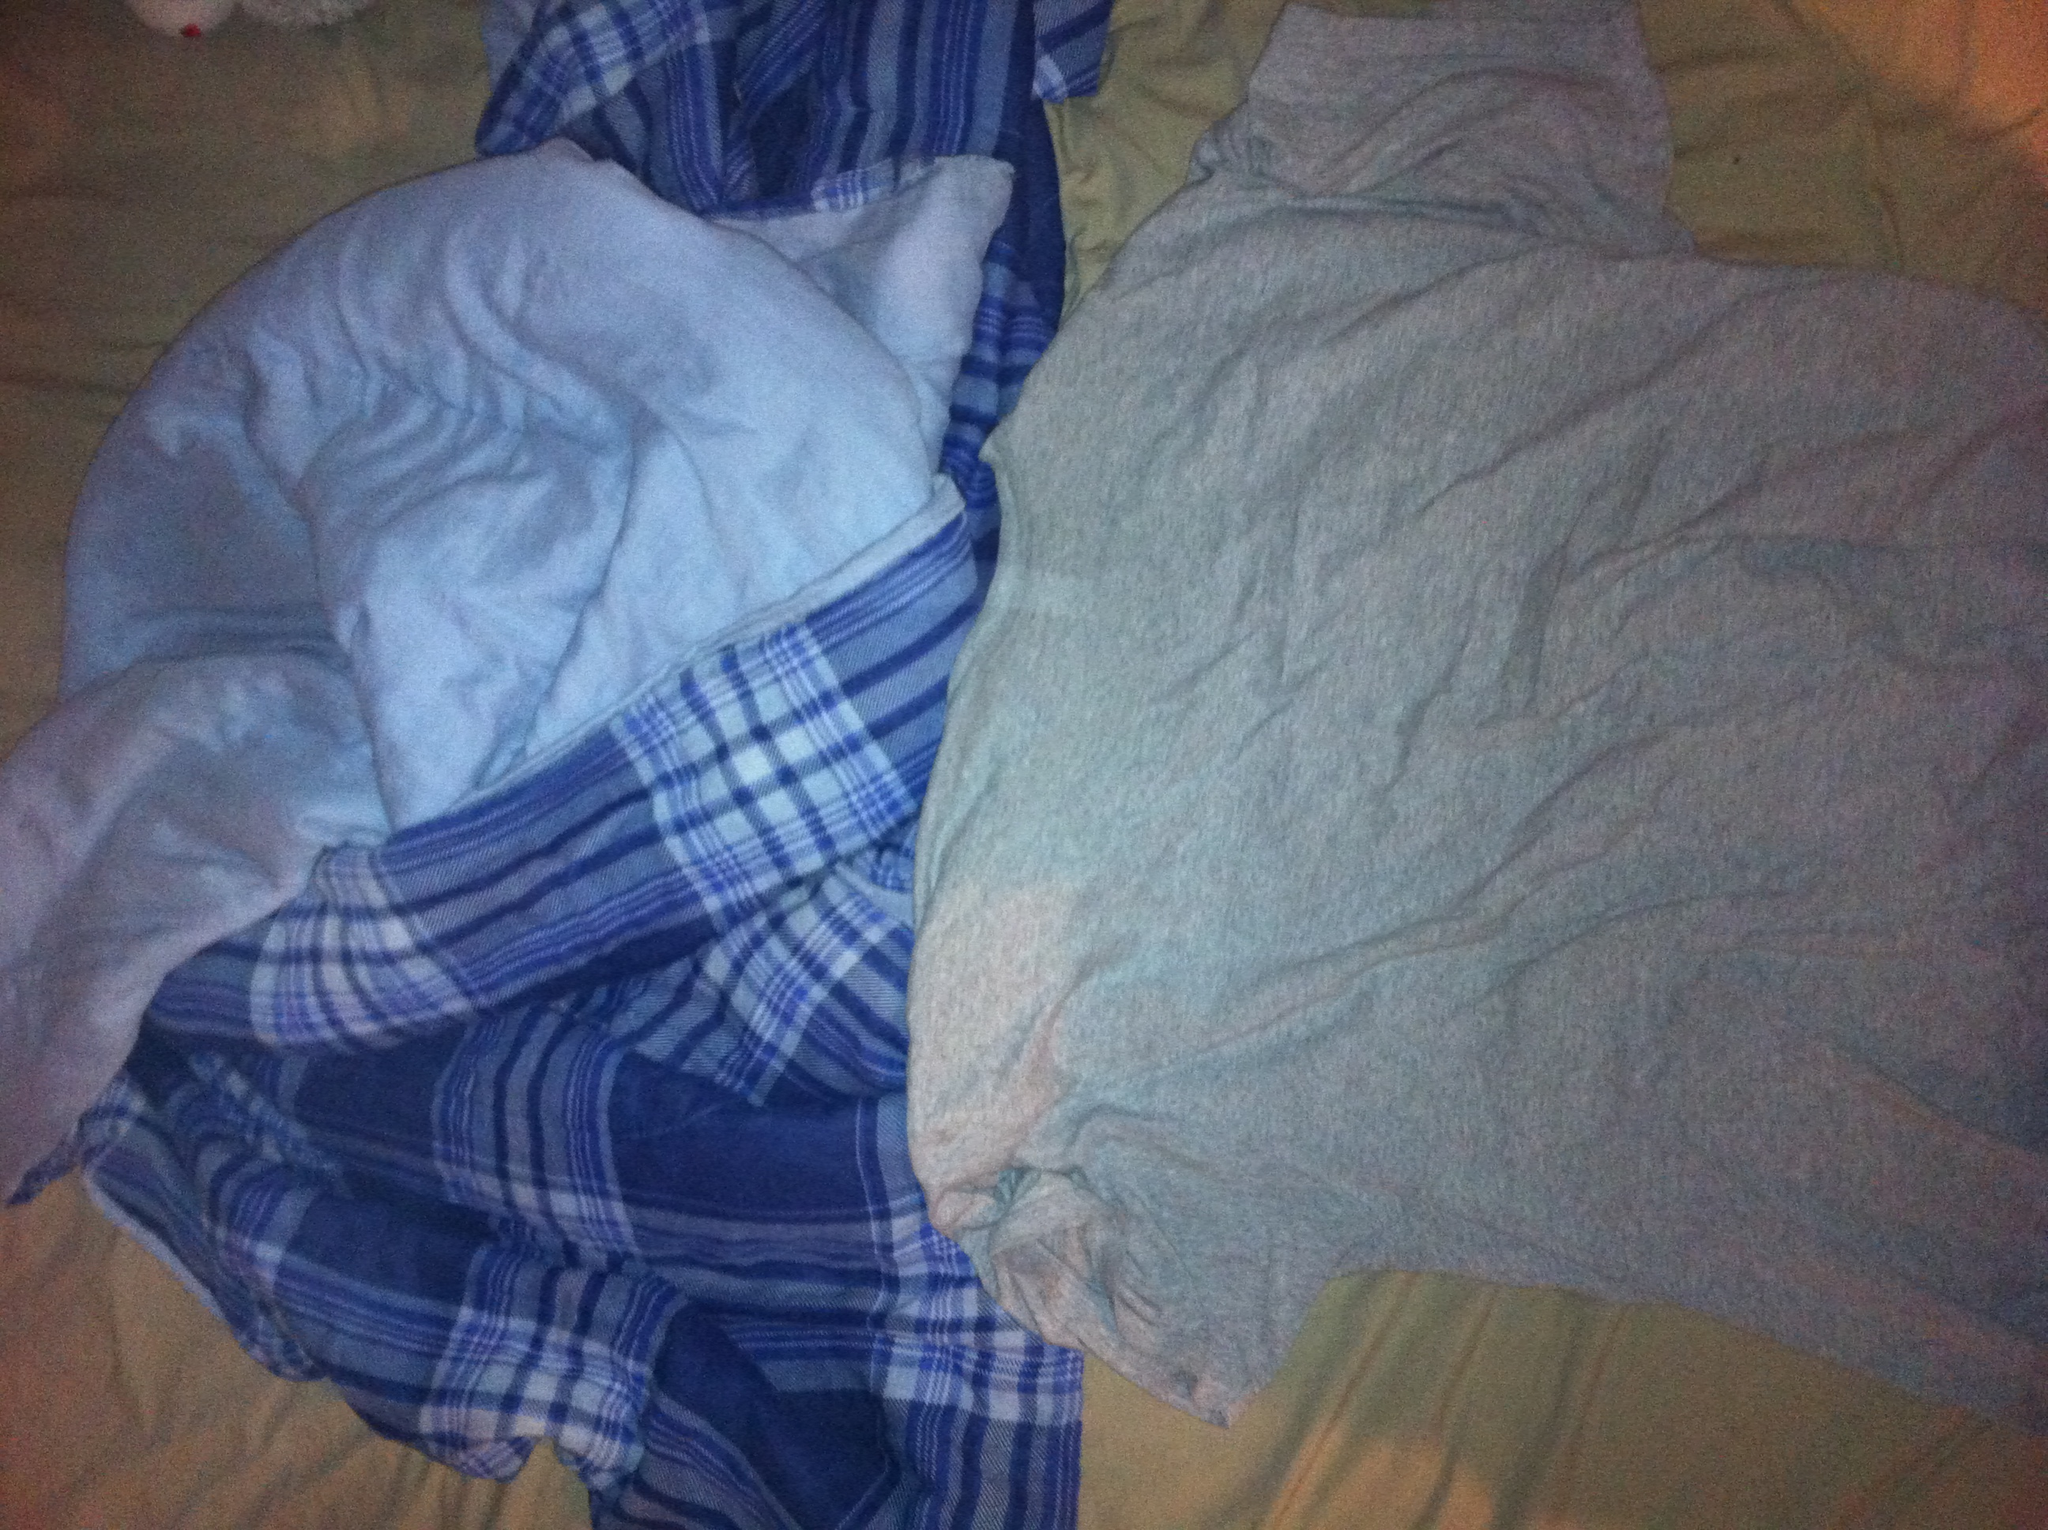Do the items in the image suggest a particular activity or time of day? Yes, the items in the image suggest a relaxed and comfortable setting, possibly associated with bedtime or lounging at home. The grey shirt and the cozy, checkered blue and white fabric might imply a scenario where someone is getting ready for bed or just waking up in the morning. Can you craft a story around these items? Certainly! Imagine a chilly autumn evening, where the air outside has a crisp bite to it. Someone is about to settle in for the night, having just put on their favorite light grey cotton shirt - its fabric soft and comforting against their skin. They curl up in a fluffy blanket adorned with blue and white checks, snuggling into their bed with a good book and a warm cup of tea. The room is dimly lit, the only sounds are the occasional rustle of the pages and the wind lightly tapping on the windows. The ambiance is serene and peaceful, offering a perfect respite at the end of a long day. Time travel to the future: describe how these items would be in a futuristic setting. In a futuristic setting, the grey shirt and checkered blanket could be integrated with advanced materials and technology. The shirt might be made from self-cleaning, temperature-regulating fabric that adjusts to perfect comfort levels automatically. The blanket could be embedded with sensors and nanotechnology, providing customized warmth and even a soothing massage feature powered by AI to ensure the ultimate relaxation experience. Both items could connect to a home automation system, adjusting settings based on the user's preferences and current state of wellbeing.  Realistically, what time of day do people most commonly use such fabrics? Realistically, these types of fabrics are most commonly used during the evening and night. People typically wear comfortable garments and use cosy blankets when they are winding down from the day, relaxing in the evening, or during sleep at night. Can you describe a short scenario involving the image? A young adult returns home after a long day at work. They change into their favorite light grey shirt and wrap themselves in a soft, checkered blue and white blanket. With a sigh of relief, they sit down on the couch, turn on a relaxing movie, and sip on a hot cup of cocoa as they unwind from the day. 